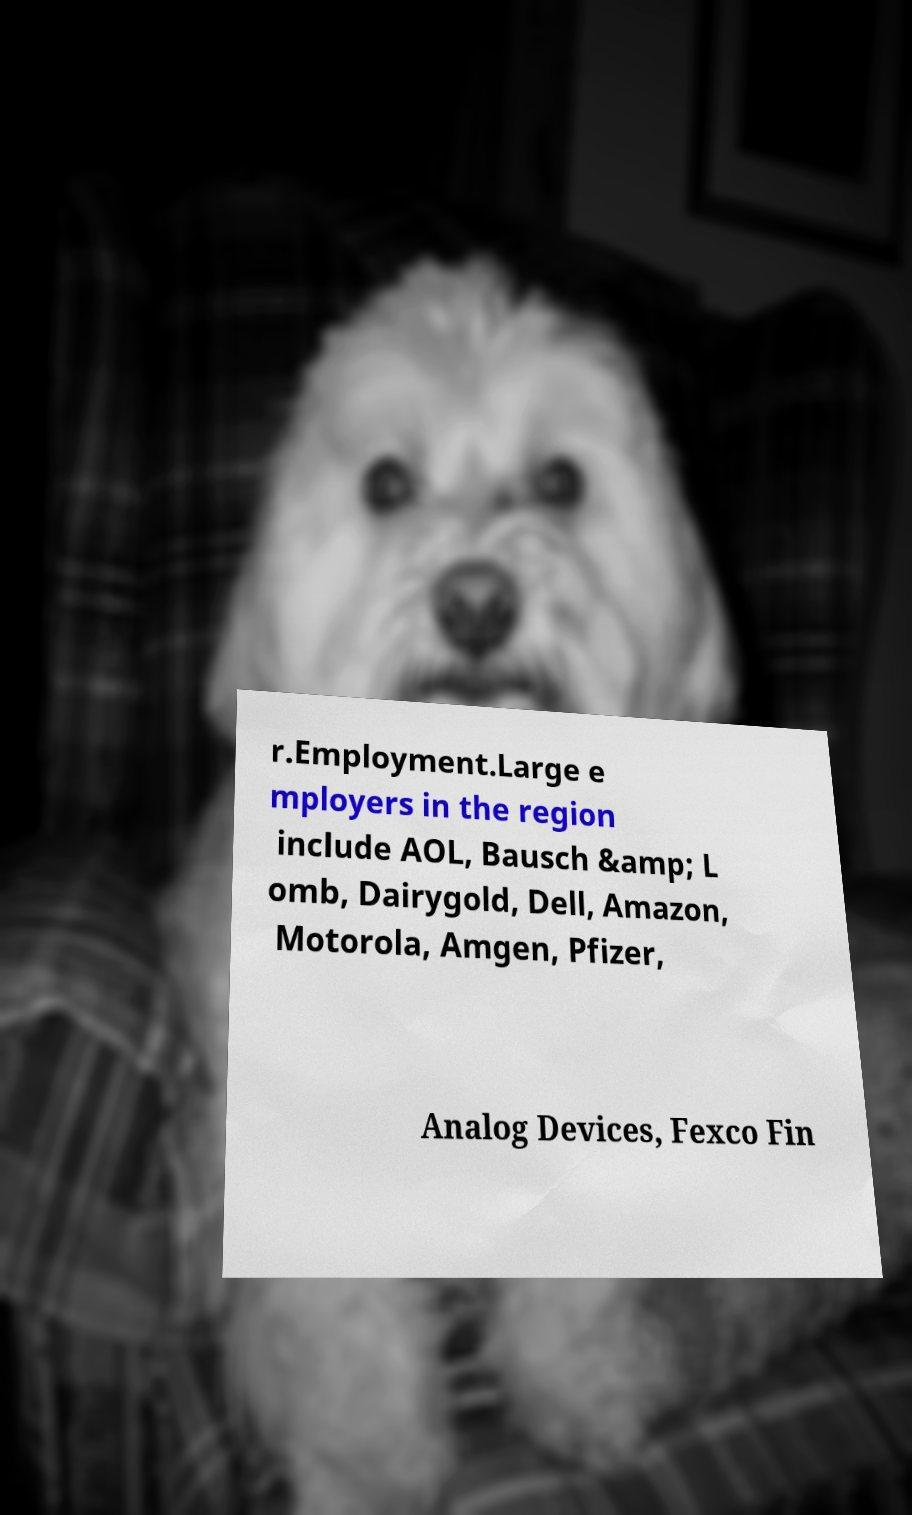What messages or text are displayed in this image? I need them in a readable, typed format. r.Employment.Large e mployers in the region include AOL, Bausch &amp; L omb, Dairygold, Dell, Amazon, Motorola, Amgen, Pfizer, Analog Devices, Fexco Fin 